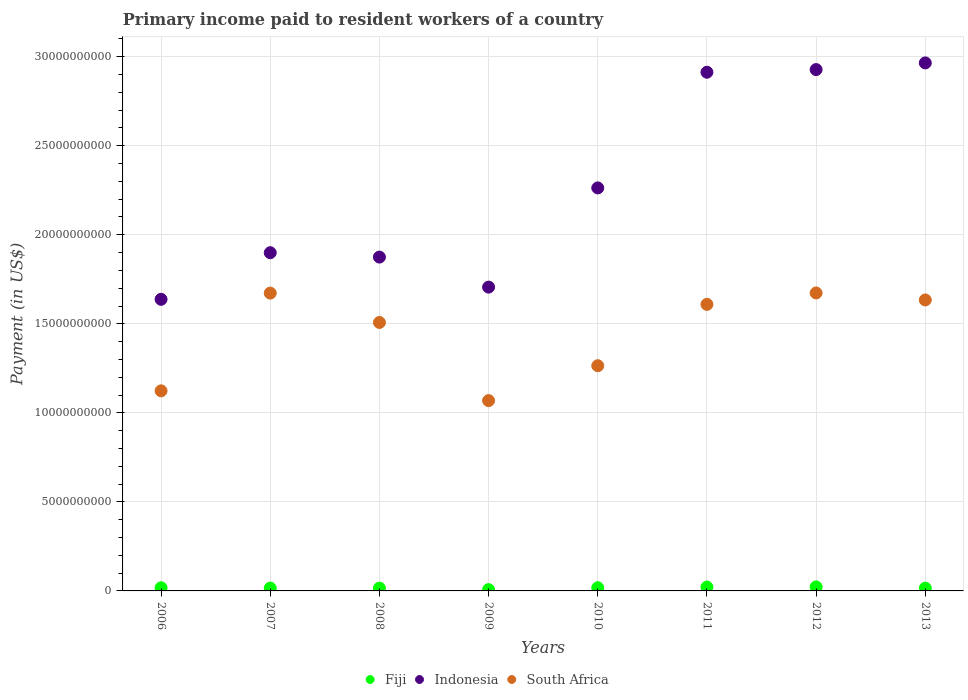How many different coloured dotlines are there?
Offer a very short reply. 3. Is the number of dotlines equal to the number of legend labels?
Your response must be concise. Yes. What is the amount paid to workers in South Africa in 2009?
Ensure brevity in your answer.  1.07e+1. Across all years, what is the maximum amount paid to workers in South Africa?
Your answer should be very brief. 1.67e+1. Across all years, what is the minimum amount paid to workers in South Africa?
Provide a short and direct response. 1.07e+1. In which year was the amount paid to workers in South Africa maximum?
Your response must be concise. 2012. What is the total amount paid to workers in South Africa in the graph?
Provide a succinct answer. 1.16e+11. What is the difference between the amount paid to workers in Indonesia in 2008 and that in 2009?
Your answer should be compact. 1.69e+09. What is the difference between the amount paid to workers in South Africa in 2012 and the amount paid to workers in Indonesia in 2010?
Keep it short and to the point. -5.90e+09. What is the average amount paid to workers in Fiji per year?
Give a very brief answer. 1.68e+08. In the year 2009, what is the difference between the amount paid to workers in Indonesia and amount paid to workers in Fiji?
Ensure brevity in your answer.  1.70e+1. What is the ratio of the amount paid to workers in South Africa in 2009 to that in 2012?
Keep it short and to the point. 0.64. What is the difference between the highest and the second highest amount paid to workers in South Africa?
Ensure brevity in your answer.  8.52e+06. What is the difference between the highest and the lowest amount paid to workers in Indonesia?
Give a very brief answer. 1.33e+1. Does the amount paid to workers in Indonesia monotonically increase over the years?
Keep it short and to the point. No. Is the amount paid to workers in Fiji strictly greater than the amount paid to workers in South Africa over the years?
Offer a terse response. No. How many dotlines are there?
Provide a short and direct response. 3. What is the difference between two consecutive major ticks on the Y-axis?
Your answer should be compact. 5.00e+09. Does the graph contain any zero values?
Keep it short and to the point. No. Does the graph contain grids?
Keep it short and to the point. Yes. How many legend labels are there?
Provide a succinct answer. 3. How are the legend labels stacked?
Your answer should be very brief. Horizontal. What is the title of the graph?
Offer a very short reply. Primary income paid to resident workers of a country. What is the label or title of the Y-axis?
Offer a terse response. Payment (in US$). What is the Payment (in US$) in Fiji in 2006?
Your answer should be very brief. 1.76e+08. What is the Payment (in US$) in Indonesia in 2006?
Your response must be concise. 1.64e+1. What is the Payment (in US$) of South Africa in 2006?
Provide a succinct answer. 1.12e+1. What is the Payment (in US$) in Fiji in 2007?
Provide a short and direct response. 1.61e+08. What is the Payment (in US$) of Indonesia in 2007?
Provide a succinct answer. 1.90e+1. What is the Payment (in US$) in South Africa in 2007?
Offer a very short reply. 1.67e+1. What is the Payment (in US$) of Fiji in 2008?
Your answer should be compact. 1.58e+08. What is the Payment (in US$) of Indonesia in 2008?
Give a very brief answer. 1.87e+1. What is the Payment (in US$) of South Africa in 2008?
Offer a very short reply. 1.51e+1. What is the Payment (in US$) of Fiji in 2009?
Provide a short and direct response. 7.33e+07. What is the Payment (in US$) in Indonesia in 2009?
Provide a short and direct response. 1.71e+1. What is the Payment (in US$) in South Africa in 2009?
Offer a terse response. 1.07e+1. What is the Payment (in US$) in Fiji in 2010?
Ensure brevity in your answer.  1.79e+08. What is the Payment (in US$) of Indonesia in 2010?
Provide a succinct answer. 2.26e+1. What is the Payment (in US$) in South Africa in 2010?
Your answer should be very brief. 1.26e+1. What is the Payment (in US$) in Fiji in 2011?
Your answer should be compact. 2.17e+08. What is the Payment (in US$) in Indonesia in 2011?
Keep it short and to the point. 2.91e+1. What is the Payment (in US$) of South Africa in 2011?
Provide a short and direct response. 1.61e+1. What is the Payment (in US$) of Fiji in 2012?
Provide a succinct answer. 2.27e+08. What is the Payment (in US$) of Indonesia in 2012?
Give a very brief answer. 2.93e+1. What is the Payment (in US$) of South Africa in 2012?
Offer a very short reply. 1.67e+1. What is the Payment (in US$) in Fiji in 2013?
Offer a terse response. 1.56e+08. What is the Payment (in US$) in Indonesia in 2013?
Your response must be concise. 2.97e+1. What is the Payment (in US$) in South Africa in 2013?
Give a very brief answer. 1.63e+1. Across all years, what is the maximum Payment (in US$) in Fiji?
Keep it short and to the point. 2.27e+08. Across all years, what is the maximum Payment (in US$) of Indonesia?
Provide a short and direct response. 2.97e+1. Across all years, what is the maximum Payment (in US$) in South Africa?
Give a very brief answer. 1.67e+1. Across all years, what is the minimum Payment (in US$) of Fiji?
Give a very brief answer. 7.33e+07. Across all years, what is the minimum Payment (in US$) in Indonesia?
Keep it short and to the point. 1.64e+1. Across all years, what is the minimum Payment (in US$) in South Africa?
Keep it short and to the point. 1.07e+1. What is the total Payment (in US$) of Fiji in the graph?
Make the answer very short. 1.35e+09. What is the total Payment (in US$) in Indonesia in the graph?
Your answer should be very brief. 1.82e+11. What is the total Payment (in US$) of South Africa in the graph?
Your response must be concise. 1.16e+11. What is the difference between the Payment (in US$) in Fiji in 2006 and that in 2007?
Provide a succinct answer. 1.55e+07. What is the difference between the Payment (in US$) of Indonesia in 2006 and that in 2007?
Make the answer very short. -2.62e+09. What is the difference between the Payment (in US$) of South Africa in 2006 and that in 2007?
Provide a succinct answer. -5.49e+09. What is the difference between the Payment (in US$) in Fiji in 2006 and that in 2008?
Offer a terse response. 1.83e+07. What is the difference between the Payment (in US$) in Indonesia in 2006 and that in 2008?
Offer a terse response. -2.37e+09. What is the difference between the Payment (in US$) in South Africa in 2006 and that in 2008?
Provide a succinct answer. -3.84e+09. What is the difference between the Payment (in US$) of Fiji in 2006 and that in 2009?
Your answer should be very brief. 1.03e+08. What is the difference between the Payment (in US$) of Indonesia in 2006 and that in 2009?
Ensure brevity in your answer.  -6.84e+08. What is the difference between the Payment (in US$) of South Africa in 2006 and that in 2009?
Offer a very short reply. 5.48e+08. What is the difference between the Payment (in US$) in Fiji in 2006 and that in 2010?
Ensure brevity in your answer.  -3.17e+06. What is the difference between the Payment (in US$) in Indonesia in 2006 and that in 2010?
Give a very brief answer. -6.26e+09. What is the difference between the Payment (in US$) in South Africa in 2006 and that in 2010?
Make the answer very short. -1.41e+09. What is the difference between the Payment (in US$) of Fiji in 2006 and that in 2011?
Keep it short and to the point. -4.04e+07. What is the difference between the Payment (in US$) of Indonesia in 2006 and that in 2011?
Make the answer very short. -1.28e+1. What is the difference between the Payment (in US$) of South Africa in 2006 and that in 2011?
Ensure brevity in your answer.  -4.86e+09. What is the difference between the Payment (in US$) in Fiji in 2006 and that in 2012?
Provide a succinct answer. -5.08e+07. What is the difference between the Payment (in US$) in Indonesia in 2006 and that in 2012?
Provide a short and direct response. -1.29e+1. What is the difference between the Payment (in US$) of South Africa in 2006 and that in 2012?
Give a very brief answer. -5.50e+09. What is the difference between the Payment (in US$) of Fiji in 2006 and that in 2013?
Your answer should be compact. 2.06e+07. What is the difference between the Payment (in US$) in Indonesia in 2006 and that in 2013?
Your answer should be compact. -1.33e+1. What is the difference between the Payment (in US$) of South Africa in 2006 and that in 2013?
Offer a terse response. -5.10e+09. What is the difference between the Payment (in US$) in Fiji in 2007 and that in 2008?
Your answer should be very brief. 2.84e+06. What is the difference between the Payment (in US$) in Indonesia in 2007 and that in 2008?
Your answer should be very brief. 2.47e+08. What is the difference between the Payment (in US$) of South Africa in 2007 and that in 2008?
Provide a succinct answer. 1.65e+09. What is the difference between the Payment (in US$) in Fiji in 2007 and that in 2009?
Offer a very short reply. 8.74e+07. What is the difference between the Payment (in US$) of Indonesia in 2007 and that in 2009?
Your response must be concise. 1.93e+09. What is the difference between the Payment (in US$) in South Africa in 2007 and that in 2009?
Provide a succinct answer. 6.04e+09. What is the difference between the Payment (in US$) in Fiji in 2007 and that in 2010?
Provide a succinct answer. -1.86e+07. What is the difference between the Payment (in US$) in Indonesia in 2007 and that in 2010?
Make the answer very short. -3.64e+09. What is the difference between the Payment (in US$) of South Africa in 2007 and that in 2010?
Keep it short and to the point. 4.08e+09. What is the difference between the Payment (in US$) of Fiji in 2007 and that in 2011?
Offer a very short reply. -5.59e+07. What is the difference between the Payment (in US$) in Indonesia in 2007 and that in 2011?
Offer a very short reply. -1.01e+1. What is the difference between the Payment (in US$) in South Africa in 2007 and that in 2011?
Your answer should be very brief. 6.33e+08. What is the difference between the Payment (in US$) of Fiji in 2007 and that in 2012?
Keep it short and to the point. -6.62e+07. What is the difference between the Payment (in US$) of Indonesia in 2007 and that in 2012?
Provide a succinct answer. -1.03e+1. What is the difference between the Payment (in US$) in South Africa in 2007 and that in 2012?
Your answer should be compact. -8.52e+06. What is the difference between the Payment (in US$) in Fiji in 2007 and that in 2013?
Ensure brevity in your answer.  5.14e+06. What is the difference between the Payment (in US$) of Indonesia in 2007 and that in 2013?
Offer a terse response. -1.07e+1. What is the difference between the Payment (in US$) in South Africa in 2007 and that in 2013?
Make the answer very short. 3.85e+08. What is the difference between the Payment (in US$) in Fiji in 2008 and that in 2009?
Offer a terse response. 8.46e+07. What is the difference between the Payment (in US$) in Indonesia in 2008 and that in 2009?
Your answer should be compact. 1.69e+09. What is the difference between the Payment (in US$) of South Africa in 2008 and that in 2009?
Make the answer very short. 4.39e+09. What is the difference between the Payment (in US$) of Fiji in 2008 and that in 2010?
Your response must be concise. -2.15e+07. What is the difference between the Payment (in US$) in Indonesia in 2008 and that in 2010?
Your answer should be compact. -3.88e+09. What is the difference between the Payment (in US$) in South Africa in 2008 and that in 2010?
Your answer should be compact. 2.43e+09. What is the difference between the Payment (in US$) of Fiji in 2008 and that in 2011?
Provide a short and direct response. -5.87e+07. What is the difference between the Payment (in US$) of Indonesia in 2008 and that in 2011?
Provide a short and direct response. -1.04e+1. What is the difference between the Payment (in US$) of South Africa in 2008 and that in 2011?
Your answer should be compact. -1.02e+09. What is the difference between the Payment (in US$) of Fiji in 2008 and that in 2012?
Offer a very short reply. -6.91e+07. What is the difference between the Payment (in US$) in Indonesia in 2008 and that in 2012?
Your response must be concise. -1.05e+1. What is the difference between the Payment (in US$) in South Africa in 2008 and that in 2012?
Provide a succinct answer. -1.66e+09. What is the difference between the Payment (in US$) of Fiji in 2008 and that in 2013?
Your answer should be compact. 2.30e+06. What is the difference between the Payment (in US$) in Indonesia in 2008 and that in 2013?
Your answer should be very brief. -1.09e+1. What is the difference between the Payment (in US$) of South Africa in 2008 and that in 2013?
Offer a terse response. -1.26e+09. What is the difference between the Payment (in US$) in Fiji in 2009 and that in 2010?
Offer a very short reply. -1.06e+08. What is the difference between the Payment (in US$) in Indonesia in 2009 and that in 2010?
Your answer should be compact. -5.57e+09. What is the difference between the Payment (in US$) in South Africa in 2009 and that in 2010?
Offer a very short reply. -1.96e+09. What is the difference between the Payment (in US$) in Fiji in 2009 and that in 2011?
Ensure brevity in your answer.  -1.43e+08. What is the difference between the Payment (in US$) of Indonesia in 2009 and that in 2011?
Make the answer very short. -1.21e+1. What is the difference between the Payment (in US$) in South Africa in 2009 and that in 2011?
Offer a very short reply. -5.40e+09. What is the difference between the Payment (in US$) in Fiji in 2009 and that in 2012?
Your response must be concise. -1.54e+08. What is the difference between the Payment (in US$) of Indonesia in 2009 and that in 2012?
Offer a terse response. -1.22e+1. What is the difference between the Payment (in US$) in South Africa in 2009 and that in 2012?
Make the answer very short. -6.05e+09. What is the difference between the Payment (in US$) of Fiji in 2009 and that in 2013?
Offer a very short reply. -8.23e+07. What is the difference between the Payment (in US$) of Indonesia in 2009 and that in 2013?
Offer a very short reply. -1.26e+1. What is the difference between the Payment (in US$) in South Africa in 2009 and that in 2013?
Your response must be concise. -5.65e+09. What is the difference between the Payment (in US$) of Fiji in 2010 and that in 2011?
Provide a succinct answer. -3.72e+07. What is the difference between the Payment (in US$) in Indonesia in 2010 and that in 2011?
Your answer should be compact. -6.50e+09. What is the difference between the Payment (in US$) of South Africa in 2010 and that in 2011?
Give a very brief answer. -3.44e+09. What is the difference between the Payment (in US$) in Fiji in 2010 and that in 2012?
Offer a terse response. -4.76e+07. What is the difference between the Payment (in US$) in Indonesia in 2010 and that in 2012?
Offer a terse response. -6.65e+09. What is the difference between the Payment (in US$) in South Africa in 2010 and that in 2012?
Your answer should be very brief. -4.09e+09. What is the difference between the Payment (in US$) in Fiji in 2010 and that in 2013?
Your answer should be very brief. 2.38e+07. What is the difference between the Payment (in US$) in Indonesia in 2010 and that in 2013?
Keep it short and to the point. -7.02e+09. What is the difference between the Payment (in US$) in South Africa in 2010 and that in 2013?
Make the answer very short. -3.69e+09. What is the difference between the Payment (in US$) of Fiji in 2011 and that in 2012?
Give a very brief answer. -1.03e+07. What is the difference between the Payment (in US$) in Indonesia in 2011 and that in 2012?
Give a very brief answer. -1.49e+08. What is the difference between the Payment (in US$) in South Africa in 2011 and that in 2012?
Your response must be concise. -6.41e+08. What is the difference between the Payment (in US$) of Fiji in 2011 and that in 2013?
Your answer should be very brief. 6.10e+07. What is the difference between the Payment (in US$) in Indonesia in 2011 and that in 2013?
Give a very brief answer. -5.24e+08. What is the difference between the Payment (in US$) in South Africa in 2011 and that in 2013?
Make the answer very short. -2.48e+08. What is the difference between the Payment (in US$) of Fiji in 2012 and that in 2013?
Offer a very short reply. 7.14e+07. What is the difference between the Payment (in US$) of Indonesia in 2012 and that in 2013?
Make the answer very short. -3.75e+08. What is the difference between the Payment (in US$) of South Africa in 2012 and that in 2013?
Ensure brevity in your answer.  3.93e+08. What is the difference between the Payment (in US$) of Fiji in 2006 and the Payment (in US$) of Indonesia in 2007?
Provide a short and direct response. -1.88e+1. What is the difference between the Payment (in US$) in Fiji in 2006 and the Payment (in US$) in South Africa in 2007?
Keep it short and to the point. -1.65e+1. What is the difference between the Payment (in US$) of Indonesia in 2006 and the Payment (in US$) of South Africa in 2007?
Make the answer very short. -3.48e+08. What is the difference between the Payment (in US$) of Fiji in 2006 and the Payment (in US$) of Indonesia in 2008?
Provide a short and direct response. -1.86e+1. What is the difference between the Payment (in US$) of Fiji in 2006 and the Payment (in US$) of South Africa in 2008?
Your answer should be compact. -1.49e+1. What is the difference between the Payment (in US$) in Indonesia in 2006 and the Payment (in US$) in South Africa in 2008?
Keep it short and to the point. 1.30e+09. What is the difference between the Payment (in US$) in Fiji in 2006 and the Payment (in US$) in Indonesia in 2009?
Offer a very short reply. -1.69e+1. What is the difference between the Payment (in US$) in Fiji in 2006 and the Payment (in US$) in South Africa in 2009?
Give a very brief answer. -1.05e+1. What is the difference between the Payment (in US$) of Indonesia in 2006 and the Payment (in US$) of South Africa in 2009?
Your response must be concise. 5.69e+09. What is the difference between the Payment (in US$) in Fiji in 2006 and the Payment (in US$) in Indonesia in 2010?
Ensure brevity in your answer.  -2.25e+1. What is the difference between the Payment (in US$) in Fiji in 2006 and the Payment (in US$) in South Africa in 2010?
Provide a short and direct response. -1.25e+1. What is the difference between the Payment (in US$) in Indonesia in 2006 and the Payment (in US$) in South Africa in 2010?
Ensure brevity in your answer.  3.73e+09. What is the difference between the Payment (in US$) of Fiji in 2006 and the Payment (in US$) of Indonesia in 2011?
Provide a succinct answer. -2.90e+1. What is the difference between the Payment (in US$) of Fiji in 2006 and the Payment (in US$) of South Africa in 2011?
Your response must be concise. -1.59e+1. What is the difference between the Payment (in US$) of Indonesia in 2006 and the Payment (in US$) of South Africa in 2011?
Provide a succinct answer. 2.85e+08. What is the difference between the Payment (in US$) of Fiji in 2006 and the Payment (in US$) of Indonesia in 2012?
Make the answer very short. -2.91e+1. What is the difference between the Payment (in US$) of Fiji in 2006 and the Payment (in US$) of South Africa in 2012?
Ensure brevity in your answer.  -1.66e+1. What is the difference between the Payment (in US$) of Indonesia in 2006 and the Payment (in US$) of South Africa in 2012?
Offer a terse response. -3.57e+08. What is the difference between the Payment (in US$) of Fiji in 2006 and the Payment (in US$) of Indonesia in 2013?
Keep it short and to the point. -2.95e+1. What is the difference between the Payment (in US$) of Fiji in 2006 and the Payment (in US$) of South Africa in 2013?
Ensure brevity in your answer.  -1.62e+1. What is the difference between the Payment (in US$) of Indonesia in 2006 and the Payment (in US$) of South Africa in 2013?
Your answer should be compact. 3.63e+07. What is the difference between the Payment (in US$) in Fiji in 2007 and the Payment (in US$) in Indonesia in 2008?
Your response must be concise. -1.86e+1. What is the difference between the Payment (in US$) of Fiji in 2007 and the Payment (in US$) of South Africa in 2008?
Offer a terse response. -1.49e+1. What is the difference between the Payment (in US$) in Indonesia in 2007 and the Payment (in US$) in South Africa in 2008?
Give a very brief answer. 3.92e+09. What is the difference between the Payment (in US$) of Fiji in 2007 and the Payment (in US$) of Indonesia in 2009?
Offer a very short reply. -1.69e+1. What is the difference between the Payment (in US$) in Fiji in 2007 and the Payment (in US$) in South Africa in 2009?
Make the answer very short. -1.05e+1. What is the difference between the Payment (in US$) in Indonesia in 2007 and the Payment (in US$) in South Africa in 2009?
Offer a terse response. 8.31e+09. What is the difference between the Payment (in US$) in Fiji in 2007 and the Payment (in US$) in Indonesia in 2010?
Provide a succinct answer. -2.25e+1. What is the difference between the Payment (in US$) in Fiji in 2007 and the Payment (in US$) in South Africa in 2010?
Offer a very short reply. -1.25e+1. What is the difference between the Payment (in US$) in Indonesia in 2007 and the Payment (in US$) in South Africa in 2010?
Provide a short and direct response. 6.35e+09. What is the difference between the Payment (in US$) in Fiji in 2007 and the Payment (in US$) in Indonesia in 2011?
Make the answer very short. -2.90e+1. What is the difference between the Payment (in US$) of Fiji in 2007 and the Payment (in US$) of South Africa in 2011?
Offer a very short reply. -1.59e+1. What is the difference between the Payment (in US$) in Indonesia in 2007 and the Payment (in US$) in South Africa in 2011?
Offer a terse response. 2.90e+09. What is the difference between the Payment (in US$) in Fiji in 2007 and the Payment (in US$) in Indonesia in 2012?
Give a very brief answer. -2.91e+1. What is the difference between the Payment (in US$) of Fiji in 2007 and the Payment (in US$) of South Africa in 2012?
Keep it short and to the point. -1.66e+1. What is the difference between the Payment (in US$) of Indonesia in 2007 and the Payment (in US$) of South Africa in 2012?
Offer a very short reply. 2.26e+09. What is the difference between the Payment (in US$) in Fiji in 2007 and the Payment (in US$) in Indonesia in 2013?
Give a very brief answer. -2.95e+1. What is the difference between the Payment (in US$) in Fiji in 2007 and the Payment (in US$) in South Africa in 2013?
Ensure brevity in your answer.  -1.62e+1. What is the difference between the Payment (in US$) of Indonesia in 2007 and the Payment (in US$) of South Africa in 2013?
Provide a succinct answer. 2.65e+09. What is the difference between the Payment (in US$) in Fiji in 2008 and the Payment (in US$) in Indonesia in 2009?
Provide a short and direct response. -1.69e+1. What is the difference between the Payment (in US$) of Fiji in 2008 and the Payment (in US$) of South Africa in 2009?
Ensure brevity in your answer.  -1.05e+1. What is the difference between the Payment (in US$) of Indonesia in 2008 and the Payment (in US$) of South Africa in 2009?
Offer a very short reply. 8.06e+09. What is the difference between the Payment (in US$) in Fiji in 2008 and the Payment (in US$) in Indonesia in 2010?
Offer a very short reply. -2.25e+1. What is the difference between the Payment (in US$) in Fiji in 2008 and the Payment (in US$) in South Africa in 2010?
Give a very brief answer. -1.25e+1. What is the difference between the Payment (in US$) of Indonesia in 2008 and the Payment (in US$) of South Africa in 2010?
Offer a terse response. 6.10e+09. What is the difference between the Payment (in US$) of Fiji in 2008 and the Payment (in US$) of Indonesia in 2011?
Give a very brief answer. -2.90e+1. What is the difference between the Payment (in US$) of Fiji in 2008 and the Payment (in US$) of South Africa in 2011?
Provide a short and direct response. -1.59e+1. What is the difference between the Payment (in US$) of Indonesia in 2008 and the Payment (in US$) of South Africa in 2011?
Keep it short and to the point. 2.66e+09. What is the difference between the Payment (in US$) in Fiji in 2008 and the Payment (in US$) in Indonesia in 2012?
Your answer should be very brief. -2.91e+1. What is the difference between the Payment (in US$) in Fiji in 2008 and the Payment (in US$) in South Africa in 2012?
Your answer should be very brief. -1.66e+1. What is the difference between the Payment (in US$) in Indonesia in 2008 and the Payment (in US$) in South Africa in 2012?
Provide a short and direct response. 2.01e+09. What is the difference between the Payment (in US$) in Fiji in 2008 and the Payment (in US$) in Indonesia in 2013?
Your answer should be compact. -2.95e+1. What is the difference between the Payment (in US$) in Fiji in 2008 and the Payment (in US$) in South Africa in 2013?
Ensure brevity in your answer.  -1.62e+1. What is the difference between the Payment (in US$) of Indonesia in 2008 and the Payment (in US$) of South Africa in 2013?
Offer a very short reply. 2.41e+09. What is the difference between the Payment (in US$) in Fiji in 2009 and the Payment (in US$) in Indonesia in 2010?
Your answer should be very brief. -2.26e+1. What is the difference between the Payment (in US$) in Fiji in 2009 and the Payment (in US$) in South Africa in 2010?
Your answer should be very brief. -1.26e+1. What is the difference between the Payment (in US$) of Indonesia in 2009 and the Payment (in US$) of South Africa in 2010?
Provide a succinct answer. 4.41e+09. What is the difference between the Payment (in US$) of Fiji in 2009 and the Payment (in US$) of Indonesia in 2011?
Keep it short and to the point. -2.91e+1. What is the difference between the Payment (in US$) in Fiji in 2009 and the Payment (in US$) in South Africa in 2011?
Ensure brevity in your answer.  -1.60e+1. What is the difference between the Payment (in US$) in Indonesia in 2009 and the Payment (in US$) in South Africa in 2011?
Make the answer very short. 9.69e+08. What is the difference between the Payment (in US$) of Fiji in 2009 and the Payment (in US$) of Indonesia in 2012?
Provide a succinct answer. -2.92e+1. What is the difference between the Payment (in US$) in Fiji in 2009 and the Payment (in US$) in South Africa in 2012?
Offer a terse response. -1.67e+1. What is the difference between the Payment (in US$) of Indonesia in 2009 and the Payment (in US$) of South Africa in 2012?
Provide a short and direct response. 3.28e+08. What is the difference between the Payment (in US$) in Fiji in 2009 and the Payment (in US$) in Indonesia in 2013?
Give a very brief answer. -2.96e+1. What is the difference between the Payment (in US$) in Fiji in 2009 and the Payment (in US$) in South Africa in 2013?
Make the answer very short. -1.63e+1. What is the difference between the Payment (in US$) in Indonesia in 2009 and the Payment (in US$) in South Africa in 2013?
Keep it short and to the point. 7.21e+08. What is the difference between the Payment (in US$) of Fiji in 2010 and the Payment (in US$) of Indonesia in 2011?
Your answer should be compact. -2.89e+1. What is the difference between the Payment (in US$) in Fiji in 2010 and the Payment (in US$) in South Africa in 2011?
Your answer should be very brief. -1.59e+1. What is the difference between the Payment (in US$) of Indonesia in 2010 and the Payment (in US$) of South Africa in 2011?
Provide a short and direct response. 6.54e+09. What is the difference between the Payment (in US$) in Fiji in 2010 and the Payment (in US$) in Indonesia in 2012?
Provide a succinct answer. -2.91e+1. What is the difference between the Payment (in US$) of Fiji in 2010 and the Payment (in US$) of South Africa in 2012?
Provide a short and direct response. -1.66e+1. What is the difference between the Payment (in US$) of Indonesia in 2010 and the Payment (in US$) of South Africa in 2012?
Your response must be concise. 5.90e+09. What is the difference between the Payment (in US$) in Fiji in 2010 and the Payment (in US$) in Indonesia in 2013?
Keep it short and to the point. -2.95e+1. What is the difference between the Payment (in US$) of Fiji in 2010 and the Payment (in US$) of South Africa in 2013?
Your answer should be very brief. -1.62e+1. What is the difference between the Payment (in US$) of Indonesia in 2010 and the Payment (in US$) of South Africa in 2013?
Give a very brief answer. 6.29e+09. What is the difference between the Payment (in US$) in Fiji in 2011 and the Payment (in US$) in Indonesia in 2012?
Offer a very short reply. -2.91e+1. What is the difference between the Payment (in US$) in Fiji in 2011 and the Payment (in US$) in South Africa in 2012?
Offer a very short reply. -1.65e+1. What is the difference between the Payment (in US$) of Indonesia in 2011 and the Payment (in US$) of South Africa in 2012?
Your answer should be very brief. 1.24e+1. What is the difference between the Payment (in US$) of Fiji in 2011 and the Payment (in US$) of Indonesia in 2013?
Offer a very short reply. -2.94e+1. What is the difference between the Payment (in US$) in Fiji in 2011 and the Payment (in US$) in South Africa in 2013?
Your answer should be compact. -1.61e+1. What is the difference between the Payment (in US$) of Indonesia in 2011 and the Payment (in US$) of South Africa in 2013?
Keep it short and to the point. 1.28e+1. What is the difference between the Payment (in US$) of Fiji in 2012 and the Payment (in US$) of Indonesia in 2013?
Offer a very short reply. -2.94e+1. What is the difference between the Payment (in US$) in Fiji in 2012 and the Payment (in US$) in South Africa in 2013?
Your answer should be very brief. -1.61e+1. What is the difference between the Payment (in US$) of Indonesia in 2012 and the Payment (in US$) of South Africa in 2013?
Offer a very short reply. 1.29e+1. What is the average Payment (in US$) of Fiji per year?
Keep it short and to the point. 1.68e+08. What is the average Payment (in US$) of Indonesia per year?
Make the answer very short. 2.27e+1. What is the average Payment (in US$) of South Africa per year?
Your answer should be compact. 1.44e+1. In the year 2006, what is the difference between the Payment (in US$) of Fiji and Payment (in US$) of Indonesia?
Give a very brief answer. -1.62e+1. In the year 2006, what is the difference between the Payment (in US$) of Fiji and Payment (in US$) of South Africa?
Give a very brief answer. -1.11e+1. In the year 2006, what is the difference between the Payment (in US$) of Indonesia and Payment (in US$) of South Africa?
Provide a short and direct response. 5.14e+09. In the year 2007, what is the difference between the Payment (in US$) in Fiji and Payment (in US$) in Indonesia?
Your answer should be compact. -1.88e+1. In the year 2007, what is the difference between the Payment (in US$) in Fiji and Payment (in US$) in South Africa?
Make the answer very short. -1.66e+1. In the year 2007, what is the difference between the Payment (in US$) of Indonesia and Payment (in US$) of South Africa?
Offer a terse response. 2.27e+09. In the year 2008, what is the difference between the Payment (in US$) of Fiji and Payment (in US$) of Indonesia?
Ensure brevity in your answer.  -1.86e+1. In the year 2008, what is the difference between the Payment (in US$) of Fiji and Payment (in US$) of South Africa?
Your answer should be compact. -1.49e+1. In the year 2008, what is the difference between the Payment (in US$) of Indonesia and Payment (in US$) of South Africa?
Offer a terse response. 3.67e+09. In the year 2009, what is the difference between the Payment (in US$) in Fiji and Payment (in US$) in Indonesia?
Your answer should be very brief. -1.70e+1. In the year 2009, what is the difference between the Payment (in US$) in Fiji and Payment (in US$) in South Africa?
Provide a short and direct response. -1.06e+1. In the year 2009, what is the difference between the Payment (in US$) of Indonesia and Payment (in US$) of South Africa?
Keep it short and to the point. 6.37e+09. In the year 2010, what is the difference between the Payment (in US$) in Fiji and Payment (in US$) in Indonesia?
Make the answer very short. -2.25e+1. In the year 2010, what is the difference between the Payment (in US$) in Fiji and Payment (in US$) in South Africa?
Your answer should be compact. -1.25e+1. In the year 2010, what is the difference between the Payment (in US$) in Indonesia and Payment (in US$) in South Africa?
Offer a terse response. 9.98e+09. In the year 2011, what is the difference between the Payment (in US$) of Fiji and Payment (in US$) of Indonesia?
Keep it short and to the point. -2.89e+1. In the year 2011, what is the difference between the Payment (in US$) in Fiji and Payment (in US$) in South Africa?
Offer a very short reply. -1.59e+1. In the year 2011, what is the difference between the Payment (in US$) of Indonesia and Payment (in US$) of South Africa?
Give a very brief answer. 1.30e+1. In the year 2012, what is the difference between the Payment (in US$) in Fiji and Payment (in US$) in Indonesia?
Ensure brevity in your answer.  -2.91e+1. In the year 2012, what is the difference between the Payment (in US$) in Fiji and Payment (in US$) in South Africa?
Ensure brevity in your answer.  -1.65e+1. In the year 2012, what is the difference between the Payment (in US$) of Indonesia and Payment (in US$) of South Africa?
Provide a short and direct response. 1.25e+1. In the year 2013, what is the difference between the Payment (in US$) in Fiji and Payment (in US$) in Indonesia?
Ensure brevity in your answer.  -2.95e+1. In the year 2013, what is the difference between the Payment (in US$) in Fiji and Payment (in US$) in South Africa?
Your response must be concise. -1.62e+1. In the year 2013, what is the difference between the Payment (in US$) in Indonesia and Payment (in US$) in South Africa?
Give a very brief answer. 1.33e+1. What is the ratio of the Payment (in US$) of Fiji in 2006 to that in 2007?
Provide a short and direct response. 1.1. What is the ratio of the Payment (in US$) in Indonesia in 2006 to that in 2007?
Offer a terse response. 0.86. What is the ratio of the Payment (in US$) in South Africa in 2006 to that in 2007?
Ensure brevity in your answer.  0.67. What is the ratio of the Payment (in US$) of Fiji in 2006 to that in 2008?
Offer a very short reply. 1.12. What is the ratio of the Payment (in US$) of Indonesia in 2006 to that in 2008?
Provide a short and direct response. 0.87. What is the ratio of the Payment (in US$) of South Africa in 2006 to that in 2008?
Your answer should be very brief. 0.75. What is the ratio of the Payment (in US$) of Fiji in 2006 to that in 2009?
Keep it short and to the point. 2.4. What is the ratio of the Payment (in US$) in Indonesia in 2006 to that in 2009?
Your answer should be very brief. 0.96. What is the ratio of the Payment (in US$) of South Africa in 2006 to that in 2009?
Your response must be concise. 1.05. What is the ratio of the Payment (in US$) in Fiji in 2006 to that in 2010?
Offer a very short reply. 0.98. What is the ratio of the Payment (in US$) of Indonesia in 2006 to that in 2010?
Your answer should be very brief. 0.72. What is the ratio of the Payment (in US$) of South Africa in 2006 to that in 2010?
Your answer should be very brief. 0.89. What is the ratio of the Payment (in US$) in Fiji in 2006 to that in 2011?
Provide a short and direct response. 0.81. What is the ratio of the Payment (in US$) of Indonesia in 2006 to that in 2011?
Provide a short and direct response. 0.56. What is the ratio of the Payment (in US$) of South Africa in 2006 to that in 2011?
Give a very brief answer. 0.7. What is the ratio of the Payment (in US$) in Fiji in 2006 to that in 2012?
Provide a succinct answer. 0.78. What is the ratio of the Payment (in US$) in Indonesia in 2006 to that in 2012?
Your answer should be very brief. 0.56. What is the ratio of the Payment (in US$) in South Africa in 2006 to that in 2012?
Provide a short and direct response. 0.67. What is the ratio of the Payment (in US$) in Fiji in 2006 to that in 2013?
Provide a succinct answer. 1.13. What is the ratio of the Payment (in US$) of Indonesia in 2006 to that in 2013?
Your answer should be compact. 0.55. What is the ratio of the Payment (in US$) in South Africa in 2006 to that in 2013?
Provide a short and direct response. 0.69. What is the ratio of the Payment (in US$) of Fiji in 2007 to that in 2008?
Provide a succinct answer. 1.02. What is the ratio of the Payment (in US$) of Indonesia in 2007 to that in 2008?
Make the answer very short. 1.01. What is the ratio of the Payment (in US$) of South Africa in 2007 to that in 2008?
Make the answer very short. 1.11. What is the ratio of the Payment (in US$) in Fiji in 2007 to that in 2009?
Provide a succinct answer. 2.19. What is the ratio of the Payment (in US$) in Indonesia in 2007 to that in 2009?
Give a very brief answer. 1.11. What is the ratio of the Payment (in US$) of South Africa in 2007 to that in 2009?
Keep it short and to the point. 1.56. What is the ratio of the Payment (in US$) in Fiji in 2007 to that in 2010?
Provide a succinct answer. 0.9. What is the ratio of the Payment (in US$) in Indonesia in 2007 to that in 2010?
Your answer should be compact. 0.84. What is the ratio of the Payment (in US$) of South Africa in 2007 to that in 2010?
Provide a succinct answer. 1.32. What is the ratio of the Payment (in US$) in Fiji in 2007 to that in 2011?
Provide a short and direct response. 0.74. What is the ratio of the Payment (in US$) of Indonesia in 2007 to that in 2011?
Keep it short and to the point. 0.65. What is the ratio of the Payment (in US$) of South Africa in 2007 to that in 2011?
Make the answer very short. 1.04. What is the ratio of the Payment (in US$) in Fiji in 2007 to that in 2012?
Give a very brief answer. 0.71. What is the ratio of the Payment (in US$) in Indonesia in 2007 to that in 2012?
Your answer should be compact. 0.65. What is the ratio of the Payment (in US$) of South Africa in 2007 to that in 2012?
Your answer should be very brief. 1. What is the ratio of the Payment (in US$) in Fiji in 2007 to that in 2013?
Offer a very short reply. 1.03. What is the ratio of the Payment (in US$) of Indonesia in 2007 to that in 2013?
Your answer should be very brief. 0.64. What is the ratio of the Payment (in US$) of South Africa in 2007 to that in 2013?
Your answer should be compact. 1.02. What is the ratio of the Payment (in US$) of Fiji in 2008 to that in 2009?
Your answer should be compact. 2.15. What is the ratio of the Payment (in US$) of Indonesia in 2008 to that in 2009?
Keep it short and to the point. 1.1. What is the ratio of the Payment (in US$) in South Africa in 2008 to that in 2009?
Make the answer very short. 1.41. What is the ratio of the Payment (in US$) of Fiji in 2008 to that in 2010?
Provide a succinct answer. 0.88. What is the ratio of the Payment (in US$) in Indonesia in 2008 to that in 2010?
Keep it short and to the point. 0.83. What is the ratio of the Payment (in US$) of South Africa in 2008 to that in 2010?
Offer a very short reply. 1.19. What is the ratio of the Payment (in US$) of Fiji in 2008 to that in 2011?
Your answer should be very brief. 0.73. What is the ratio of the Payment (in US$) of Indonesia in 2008 to that in 2011?
Offer a terse response. 0.64. What is the ratio of the Payment (in US$) of South Africa in 2008 to that in 2011?
Provide a succinct answer. 0.94. What is the ratio of the Payment (in US$) of Fiji in 2008 to that in 2012?
Offer a very short reply. 0.7. What is the ratio of the Payment (in US$) of Indonesia in 2008 to that in 2012?
Your answer should be very brief. 0.64. What is the ratio of the Payment (in US$) of South Africa in 2008 to that in 2012?
Your answer should be very brief. 0.9. What is the ratio of the Payment (in US$) in Fiji in 2008 to that in 2013?
Provide a succinct answer. 1.01. What is the ratio of the Payment (in US$) in Indonesia in 2008 to that in 2013?
Make the answer very short. 0.63. What is the ratio of the Payment (in US$) of South Africa in 2008 to that in 2013?
Keep it short and to the point. 0.92. What is the ratio of the Payment (in US$) in Fiji in 2009 to that in 2010?
Offer a very short reply. 0.41. What is the ratio of the Payment (in US$) of Indonesia in 2009 to that in 2010?
Provide a succinct answer. 0.75. What is the ratio of the Payment (in US$) in South Africa in 2009 to that in 2010?
Provide a succinct answer. 0.85. What is the ratio of the Payment (in US$) of Fiji in 2009 to that in 2011?
Your answer should be compact. 0.34. What is the ratio of the Payment (in US$) in Indonesia in 2009 to that in 2011?
Keep it short and to the point. 0.59. What is the ratio of the Payment (in US$) in South Africa in 2009 to that in 2011?
Give a very brief answer. 0.66. What is the ratio of the Payment (in US$) of Fiji in 2009 to that in 2012?
Provide a succinct answer. 0.32. What is the ratio of the Payment (in US$) of Indonesia in 2009 to that in 2012?
Your answer should be very brief. 0.58. What is the ratio of the Payment (in US$) of South Africa in 2009 to that in 2012?
Keep it short and to the point. 0.64. What is the ratio of the Payment (in US$) of Fiji in 2009 to that in 2013?
Provide a succinct answer. 0.47. What is the ratio of the Payment (in US$) of Indonesia in 2009 to that in 2013?
Offer a very short reply. 0.58. What is the ratio of the Payment (in US$) of South Africa in 2009 to that in 2013?
Your response must be concise. 0.65. What is the ratio of the Payment (in US$) in Fiji in 2010 to that in 2011?
Offer a terse response. 0.83. What is the ratio of the Payment (in US$) of Indonesia in 2010 to that in 2011?
Keep it short and to the point. 0.78. What is the ratio of the Payment (in US$) of South Africa in 2010 to that in 2011?
Keep it short and to the point. 0.79. What is the ratio of the Payment (in US$) of Fiji in 2010 to that in 2012?
Your answer should be compact. 0.79. What is the ratio of the Payment (in US$) in Indonesia in 2010 to that in 2012?
Offer a very short reply. 0.77. What is the ratio of the Payment (in US$) in South Africa in 2010 to that in 2012?
Your answer should be very brief. 0.76. What is the ratio of the Payment (in US$) of Fiji in 2010 to that in 2013?
Keep it short and to the point. 1.15. What is the ratio of the Payment (in US$) in Indonesia in 2010 to that in 2013?
Offer a terse response. 0.76. What is the ratio of the Payment (in US$) of South Africa in 2010 to that in 2013?
Keep it short and to the point. 0.77. What is the ratio of the Payment (in US$) of Fiji in 2011 to that in 2012?
Offer a terse response. 0.95. What is the ratio of the Payment (in US$) of Indonesia in 2011 to that in 2012?
Your response must be concise. 0.99. What is the ratio of the Payment (in US$) in South Africa in 2011 to that in 2012?
Your response must be concise. 0.96. What is the ratio of the Payment (in US$) in Fiji in 2011 to that in 2013?
Make the answer very short. 1.39. What is the ratio of the Payment (in US$) of Indonesia in 2011 to that in 2013?
Give a very brief answer. 0.98. What is the ratio of the Payment (in US$) of Fiji in 2012 to that in 2013?
Give a very brief answer. 1.46. What is the ratio of the Payment (in US$) of Indonesia in 2012 to that in 2013?
Provide a succinct answer. 0.99. What is the ratio of the Payment (in US$) of South Africa in 2012 to that in 2013?
Ensure brevity in your answer.  1.02. What is the difference between the highest and the second highest Payment (in US$) in Fiji?
Your response must be concise. 1.03e+07. What is the difference between the highest and the second highest Payment (in US$) in Indonesia?
Your answer should be very brief. 3.75e+08. What is the difference between the highest and the second highest Payment (in US$) in South Africa?
Ensure brevity in your answer.  8.52e+06. What is the difference between the highest and the lowest Payment (in US$) in Fiji?
Your response must be concise. 1.54e+08. What is the difference between the highest and the lowest Payment (in US$) of Indonesia?
Provide a succinct answer. 1.33e+1. What is the difference between the highest and the lowest Payment (in US$) of South Africa?
Provide a succinct answer. 6.05e+09. 